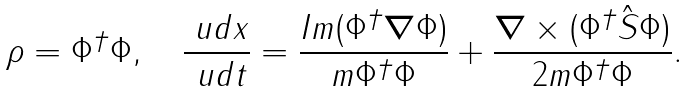Convert formula to latex. <formula><loc_0><loc_0><loc_500><loc_500>\rho = \Phi ^ { \dagger } \Phi , \quad \frac { \ u d { x } } { \ u d t } = \frac { I m ( \Phi ^ { \dagger } { \boldsymbol \nabla } \Phi ) } { m \Phi ^ { \dagger } \Phi } + \frac { { \boldsymbol \nabla } \times ( \Phi ^ { \dagger } { \hat { S } } \Phi ) } { 2 m \Phi ^ { \dagger } \Phi } .</formula> 